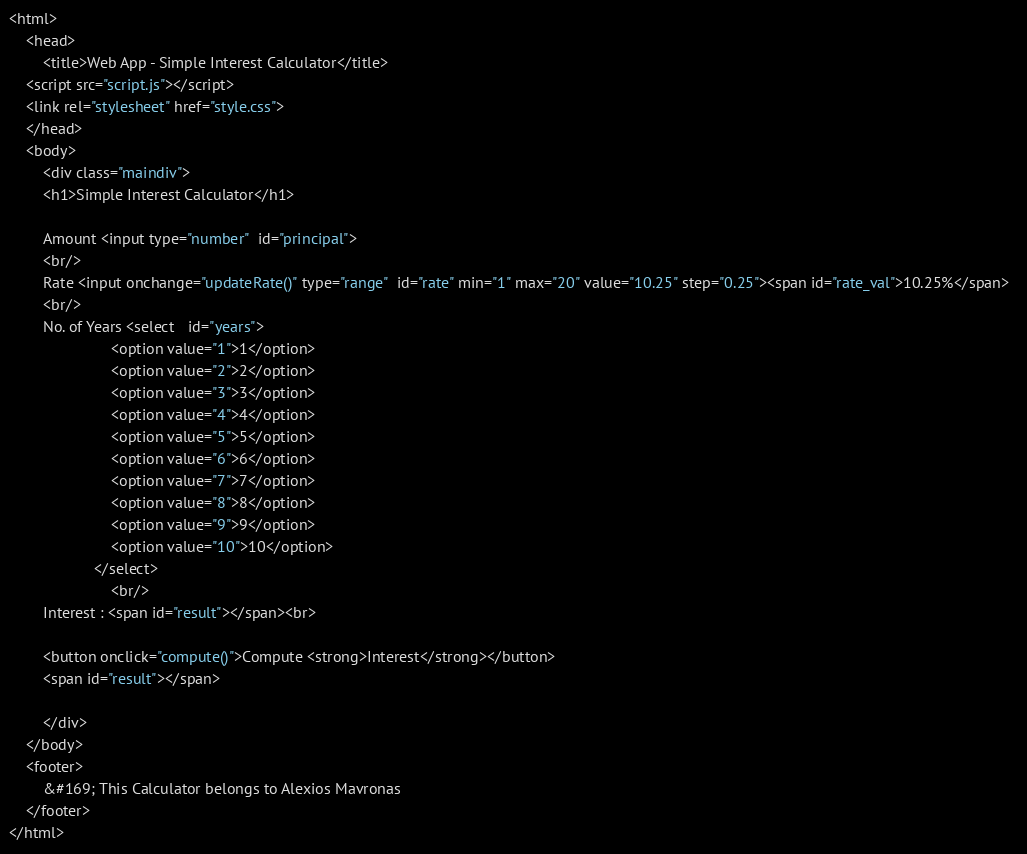Convert code to text. <code><loc_0><loc_0><loc_500><loc_500><_HTML_><html>
    <head>
        <title>Web App - Simple Interest Calculator</title>
    <script src="script.js"></script>
    <link rel="stylesheet" href="style.css">
    </head>
    <body>
        <div class="maindiv">
        <h1>Simple Interest Calculator</h1>

        Amount <input type="number"  id="principal">  
        <br/>
        Rate <input onchange="updateRate()" type="range"  id="rate" min="1" max="20" value="10.25" step="0.25"><span id="rate_val">10.25%</span>  
        <br/>
        No. of Years <select   id="years">
                        <option value="1">1</option>
                        <option value="2">2</option>
                        <option value="3">3</option>
                        <option value="4">4</option>
                        <option value="5">5</option>
                        <option value="6">6</option>
                        <option value="7">7</option>
                        <option value="8">8</option>
                        <option value="9">9</option>
                        <option value="10">10</option>  
                    </select>
                        <br/>
        Interest : <span id="result"></span><br>

        <button onclick="compute()">Compute <strong>Interest</strong></button>
        <span id="result"></span>
        
        </div>
    </body>
    <footer>
        &#169; This Calculator belongs to Alexios Mavronas
    </footer>
</html>
</code> 